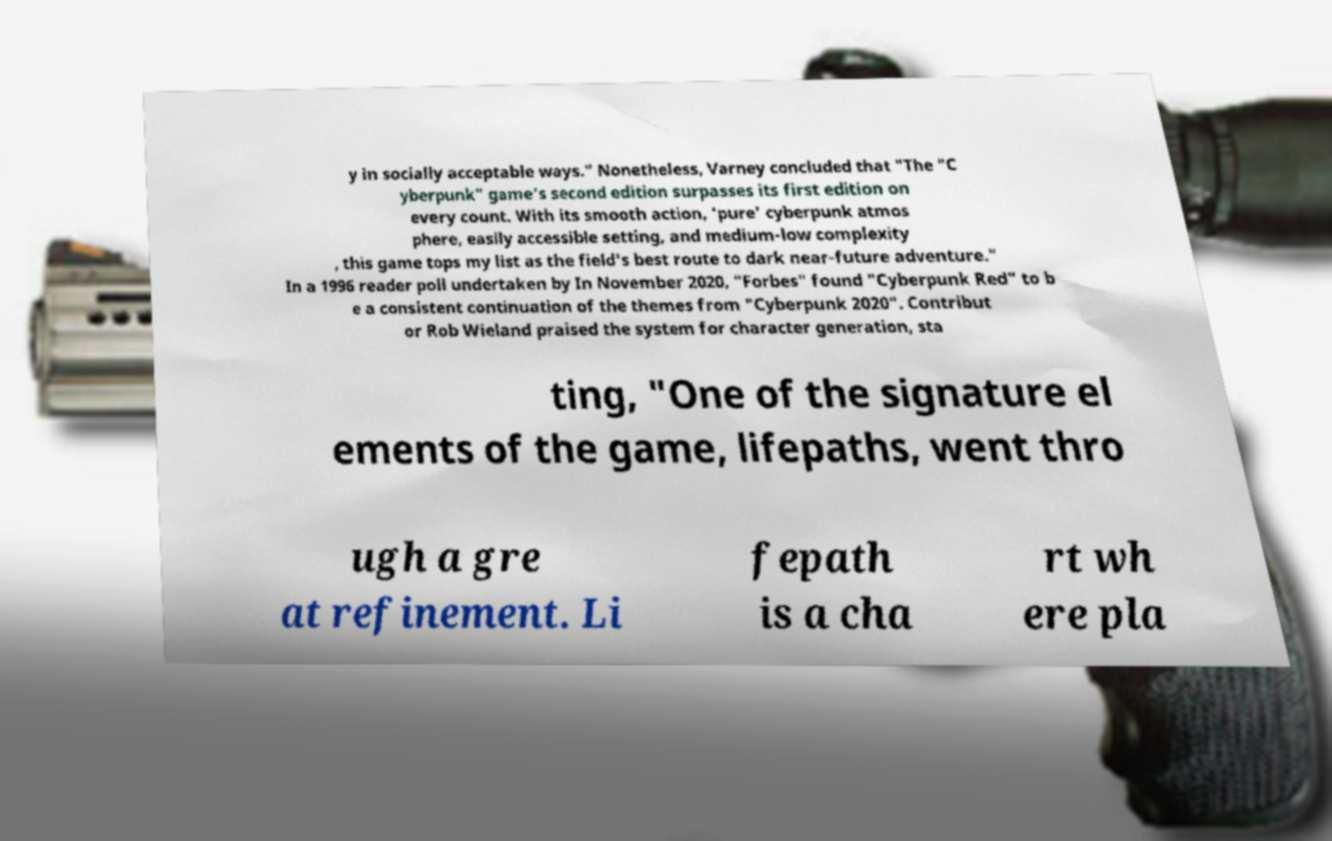There's text embedded in this image that I need extracted. Can you transcribe it verbatim? y in socially acceptable ways." Nonetheless, Varney concluded that "The "C yberpunk" game’s second edition surpasses its first edition on every count. With its smooth action, 'pure' cyberpunk atmos phere, easily accessible setting, and medium-low complexity , this game tops my list as the field's best route to dark near-future adventure." In a 1996 reader poll undertaken by In November 2020, "Forbes" found "Cyberpunk Red" to b e a consistent continuation of the themes from "Cyberpunk 2020". Contribut or Rob Wieland praised the system for character generation, sta ting, "One of the signature el ements of the game, lifepaths, went thro ugh a gre at refinement. Li fepath is a cha rt wh ere pla 